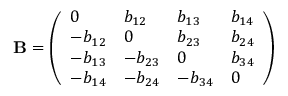<formula> <loc_0><loc_0><loc_500><loc_500>B = \left ( \begin{array} { l l l l } { 0 } & { b _ { 1 2 } } & { b _ { 1 3 } } & { b _ { 1 4 } } \\ { - b _ { 1 2 } } & { 0 } & { b _ { 2 3 } } & { b _ { 2 4 } } \\ { - b _ { 1 3 } } & { - b _ { 2 3 } } & { 0 } & { b _ { 3 4 } } \\ { - b _ { 1 4 } } & { - b _ { 2 4 } } & { - b _ { 3 4 } } & { 0 } \end{array} \right )</formula> 